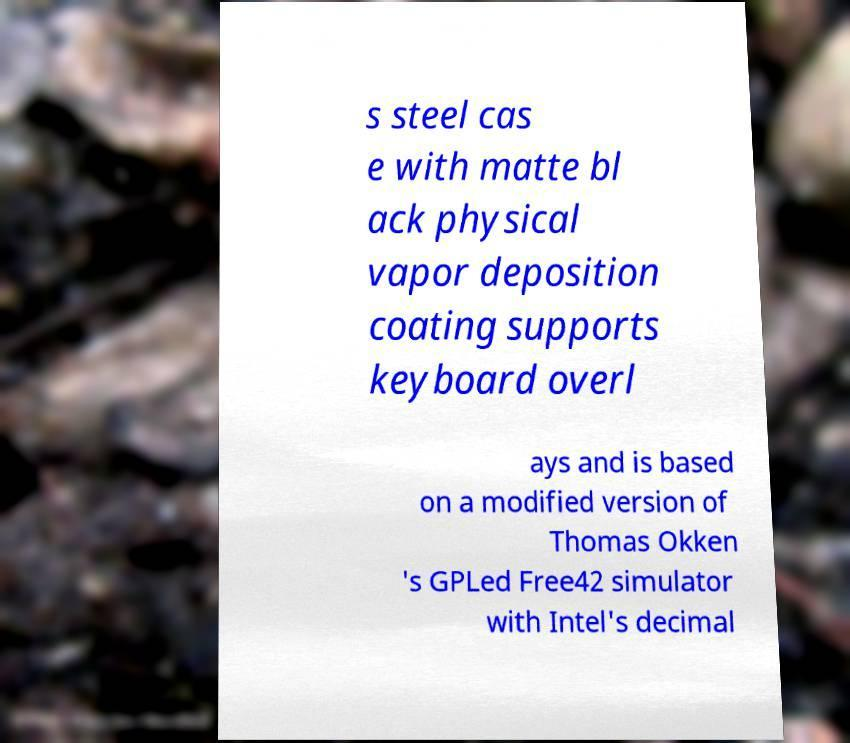There's text embedded in this image that I need extracted. Can you transcribe it verbatim? s steel cas e with matte bl ack physical vapor deposition coating supports keyboard overl ays and is based on a modified version of Thomas Okken 's GPLed Free42 simulator with Intel's decimal 